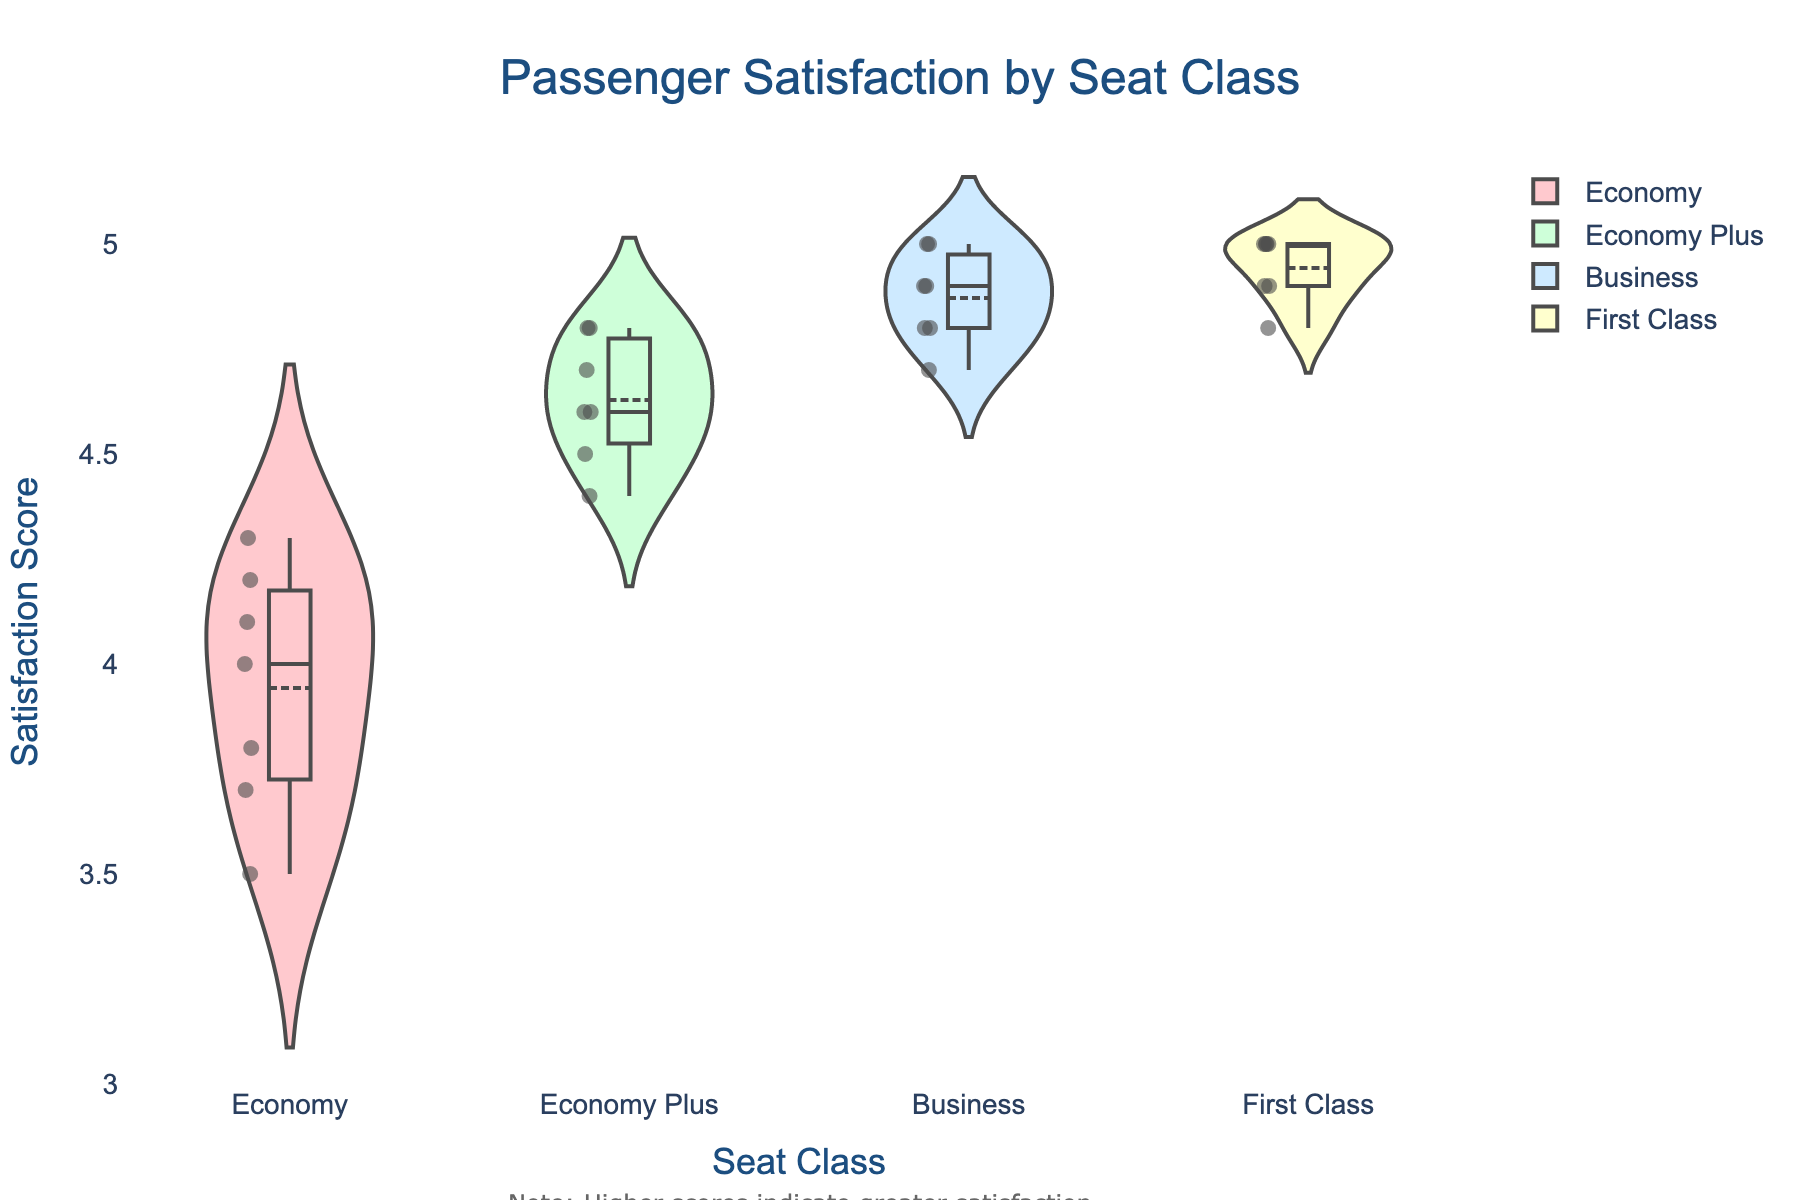What's the title of the figure? The title of the figure is written prominently at the top center in larger, bold font.
Answer: Passenger Satisfaction by Seat Class Which seat class has the highest median satisfaction score? Each violin plot has a horizontal line that represents the median value. The median line in the First Class plot is highest and appears at 5.0.
Answer: First Class What is the range of satisfaction scores for Economy class? Look at the vertical extent of the Economy class violin plot. The lowest value is around 3.5 and the highest is around 4.3.
Answer: 3.5 to 4.3 How do the average satisfaction scores compare between Economy Plus and Business class? Each violin plot has a horizontal line representing the mean (average). The mean value for Business seems slightly higher than that for Economy Plus.
Answer: Business > Economy Plus Which seat class shows the most variation in satisfaction scores? The 'width' of the violin plots indicates the distribution. The wider the plot, the more variation there is. The Economy class plot is the widest, indicating the highest variation.
Answer: Economy Can you identify any outliers in Business class? Outliers would show as individual points distinct from the main body of the violin plot. In Business class, there are no points outside the main body of the distribution.
Answer: No outliers What's the most common satisfaction score for First Class? The widest part of the violin indicates the most common value. For First Class, the widest section is at the top of the plot, at satisfaction score 5.0.
Answer: 5.0 What is the median satisfaction score for Economy Plus? The horizontal line across the middle of the violin plot in Economy Plus represents the median. This line seems to be around 4.6.
Answer: 4.6 How does the top end of the satisfaction range for Economy Plus compare to First Class? The highest point of the Economy Plus plot is around 4.8, whereas First Class reaches 5.0.
Answer: First Class > Economy Plus Is the median higher or lower than the mean satisfaction score in Economy class? The mean line is depicted by a white point, while the median is a horizontal black line. The median appears higher than the mean in Economy class.
Answer: Median > Mean 